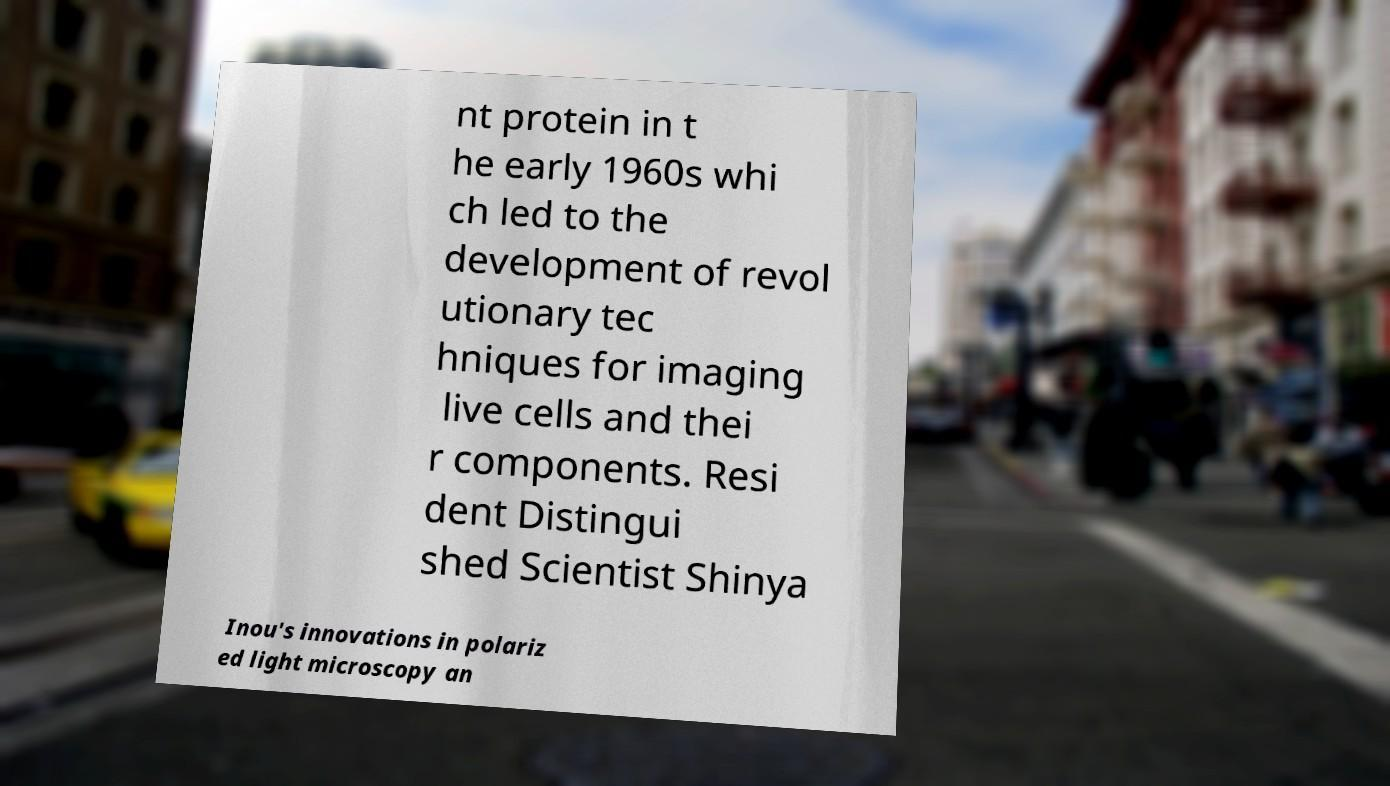Could you extract and type out the text from this image? nt protein in t he early 1960s whi ch led to the development of revol utionary tec hniques for imaging live cells and thei r components. Resi dent Distingui shed Scientist Shinya Inou's innovations in polariz ed light microscopy an 